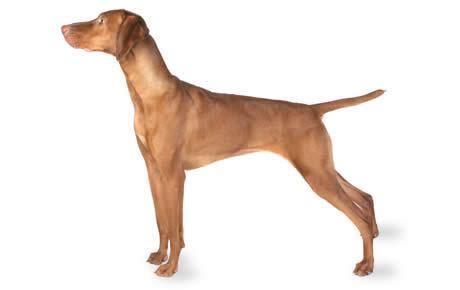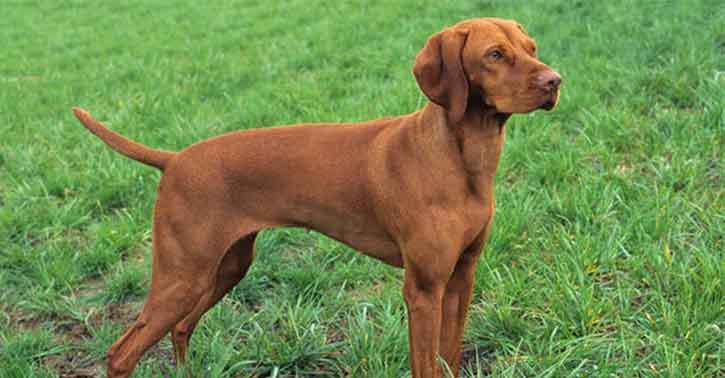The first image is the image on the left, the second image is the image on the right. Evaluate the accuracy of this statement regarding the images: "The dog in each of the images is standing up on all four.". Is it true? Answer yes or no. Yes. 